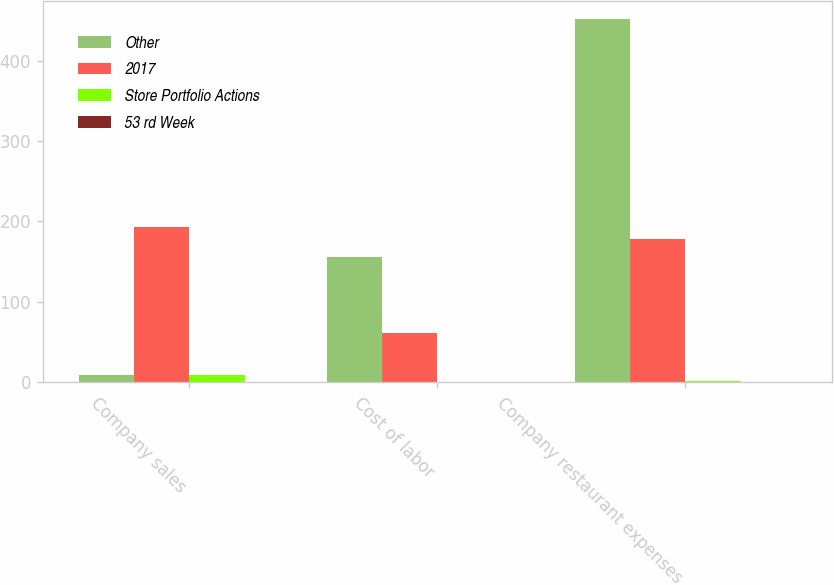<chart> <loc_0><loc_0><loc_500><loc_500><stacked_bar_chart><ecel><fcel>Company sales<fcel>Cost of labor<fcel>Company restaurant expenses<nl><fcel>Other<fcel>9<fcel>156<fcel>452<nl><fcel>2017<fcel>193<fcel>61<fcel>178<nl><fcel>Store Portfolio Actions<fcel>9<fcel>1<fcel>2<nl><fcel>53 rd Week<fcel>1<fcel>1<fcel>1<nl></chart> 